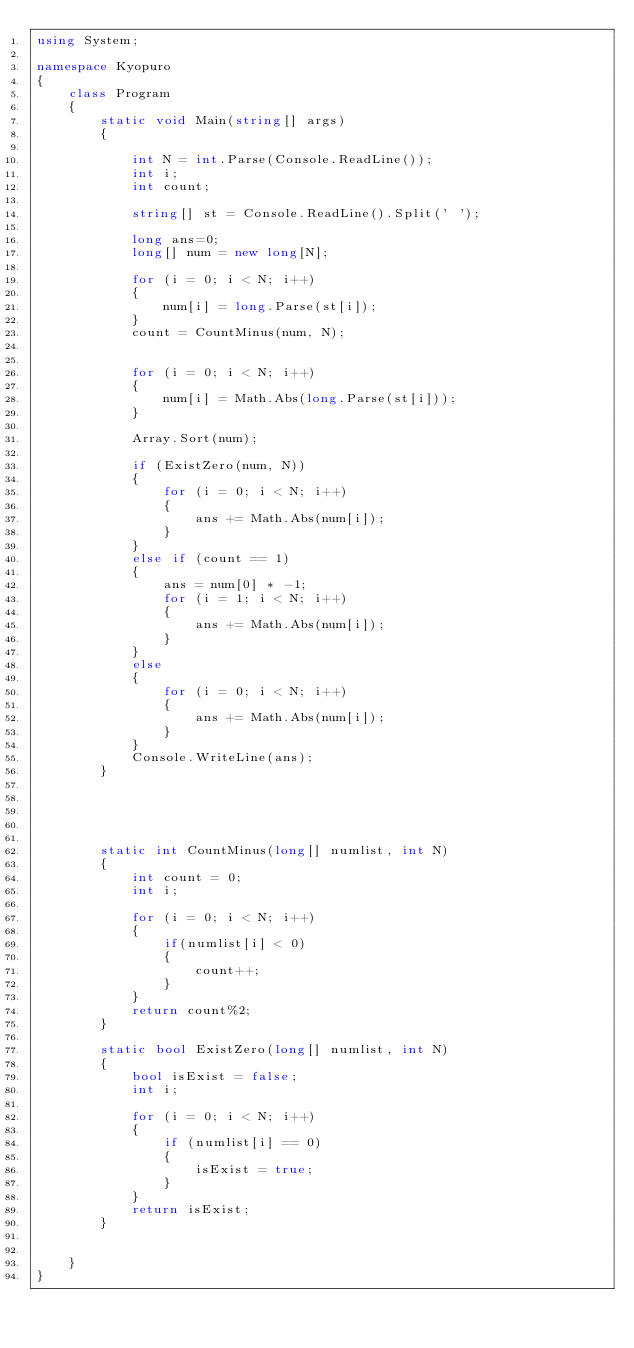<code> <loc_0><loc_0><loc_500><loc_500><_C#_>using System;

namespace Kyopuro
{
    class Program
    {
        static void Main(string[] args)
        {

            int N = int.Parse(Console.ReadLine());
            int i;
            int count;

            string[] st = Console.ReadLine().Split(' ');

            long ans=0;
            long[] num = new long[N];

            for (i = 0; i < N; i++)
            {
                num[i] = long.Parse(st[i]);
            }
            count = CountMinus(num, N);


            for (i = 0; i < N; i++)
            {
                num[i] = Math.Abs(long.Parse(st[i]));
            }

            Array.Sort(num);

            if (ExistZero(num, N))
            {
                for (i = 0; i < N; i++)
                {
                    ans += Math.Abs(num[i]);
                }
            }
            else if (count == 1)
            {
                ans = num[0] * -1;
                for (i = 1; i < N; i++)
                {
                    ans += Math.Abs(num[i]);
                }
            }
            else
            {
                for (i = 0; i < N; i++)
                {
                    ans += Math.Abs(num[i]);
                }
            }
            Console.WriteLine(ans);
        }





        static int CountMinus(long[] numlist, int N)
        {
            int count = 0;
            int i;

            for (i = 0; i < N; i++)
            {
                if(numlist[i] < 0)
                {
                    count++;
                }
            }
            return count%2;
        }

        static bool ExistZero(long[] numlist, int N)
        {
            bool isExist = false;
            int i;

            for (i = 0; i < N; i++)
            {
                if (numlist[i] == 0)
                {
                    isExist = true;
                }
            }
            return isExist;
        }


    }
}</code> 